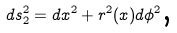<formula> <loc_0><loc_0><loc_500><loc_500>d s _ { 2 } ^ { 2 } = d x ^ { 2 } + r ^ { 2 } ( x ) d \phi ^ { 2 } \text {,}</formula> 